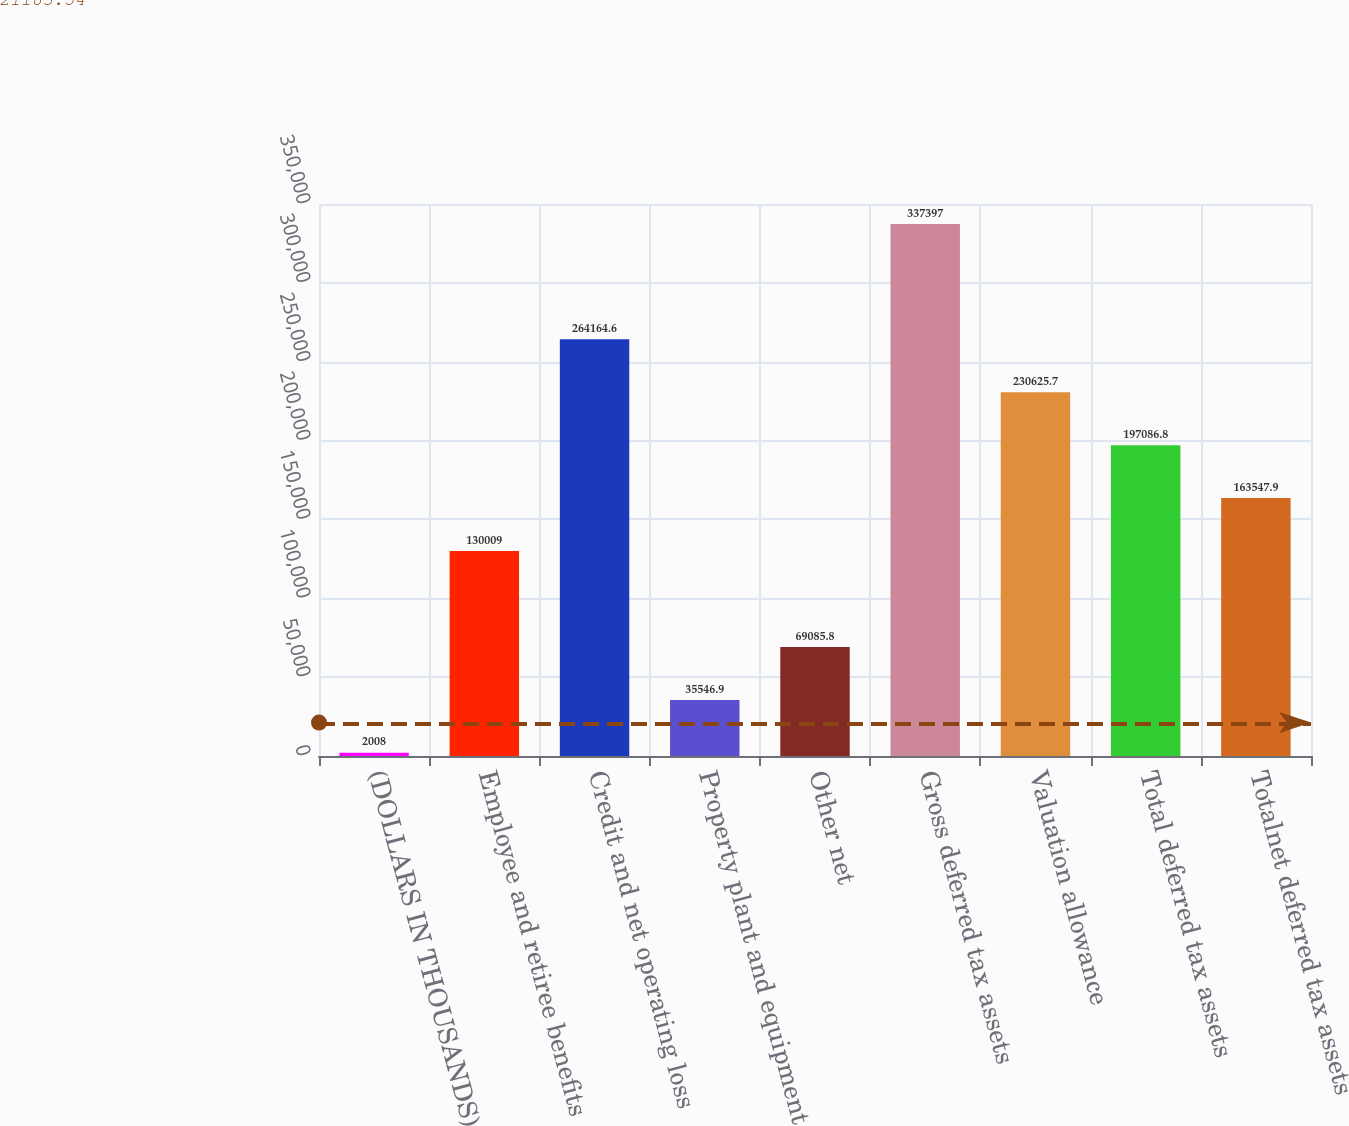Convert chart to OTSL. <chart><loc_0><loc_0><loc_500><loc_500><bar_chart><fcel>(DOLLARS IN THOUSANDS)<fcel>Employee and retiree benefits<fcel>Credit and net operating loss<fcel>Property plant and equipment<fcel>Other net<fcel>Gross deferred tax assets<fcel>Valuation allowance<fcel>Total deferred tax assets<fcel>Totalnet deferred tax assets<nl><fcel>2008<fcel>130009<fcel>264165<fcel>35546.9<fcel>69085.8<fcel>337397<fcel>230626<fcel>197087<fcel>163548<nl></chart> 